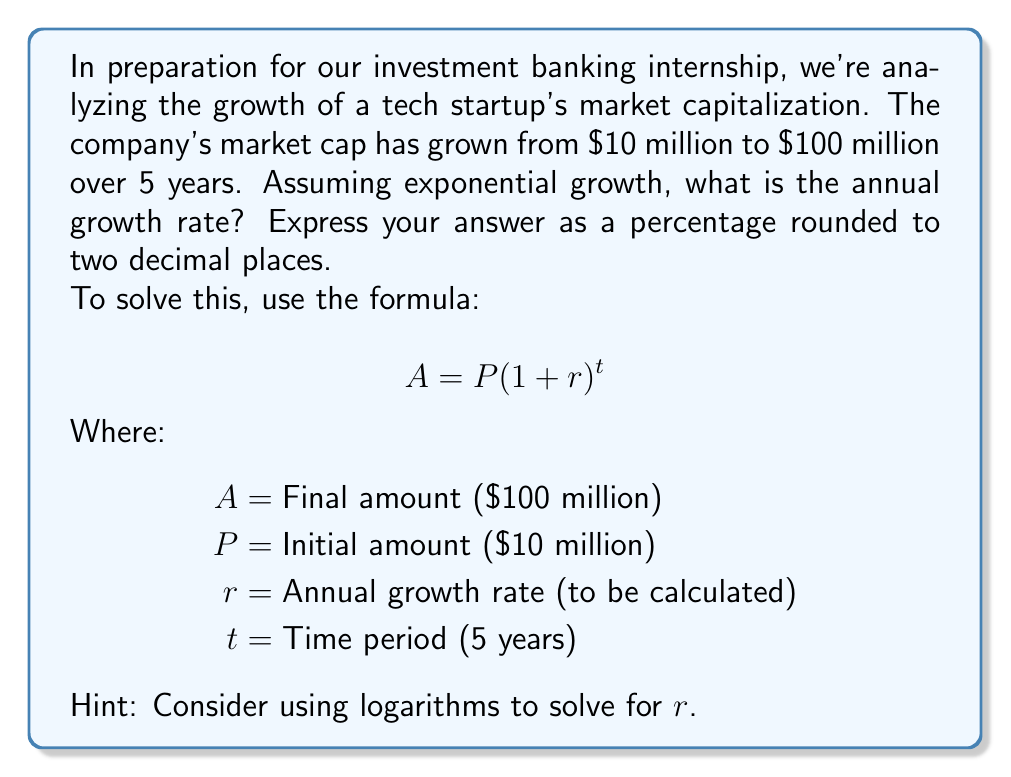Can you answer this question? Let's approach this step-by-step:

1) We start with the exponential growth formula:
   $$100 = 10(1+r)^5$$

2) Divide both sides by 10:
   $$10 = (1+r)^5$$

3) Take the natural logarithm of both sides:
   $$\ln(10) = 5\ln(1+r)$$

4) Divide both sides by 5:
   $$\frac{\ln(10)}{5} = \ln(1+r)$$

5) Apply the exponential function to both sides:
   $$e^{\frac{\ln(10)}{5}} = e^{\ln(1+r)} = 1+r$$

6) Subtract 1 from both sides:
   $$e^{\frac{\ln(10)}{5}} - 1 = r$$

7) Calculate:
   $$r = e^{\frac{\ln(10)}{5}} - 1 \approx 0.5848 \text{ or } 58.48\%$$

8) Round to two decimal places: 58.48%
Answer: 58.48% 